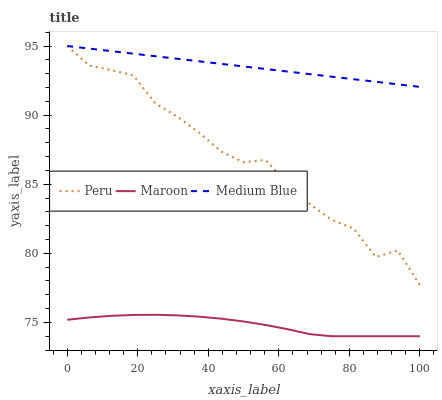Does Maroon have the minimum area under the curve?
Answer yes or no. Yes. Does Medium Blue have the maximum area under the curve?
Answer yes or no. Yes. Does Peru have the minimum area under the curve?
Answer yes or no. No. Does Peru have the maximum area under the curve?
Answer yes or no. No. Is Medium Blue the smoothest?
Answer yes or no. Yes. Is Peru the roughest?
Answer yes or no. Yes. Is Maroon the smoothest?
Answer yes or no. No. Is Maroon the roughest?
Answer yes or no. No. Does Peru have the lowest value?
Answer yes or no. No. Does Maroon have the highest value?
Answer yes or no. No. Is Maroon less than Peru?
Answer yes or no. Yes. Is Medium Blue greater than Maroon?
Answer yes or no. Yes. Does Maroon intersect Peru?
Answer yes or no. No. 